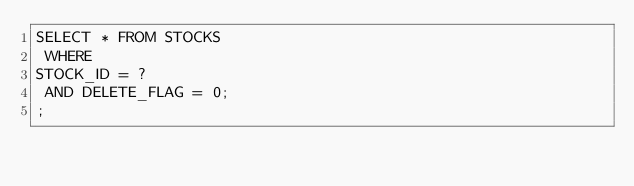<code> <loc_0><loc_0><loc_500><loc_500><_SQL_>SELECT * FROM STOCKS
 WHERE 
STOCK_ID = ?
 AND DELETE_FLAG = 0;
;
</code> 